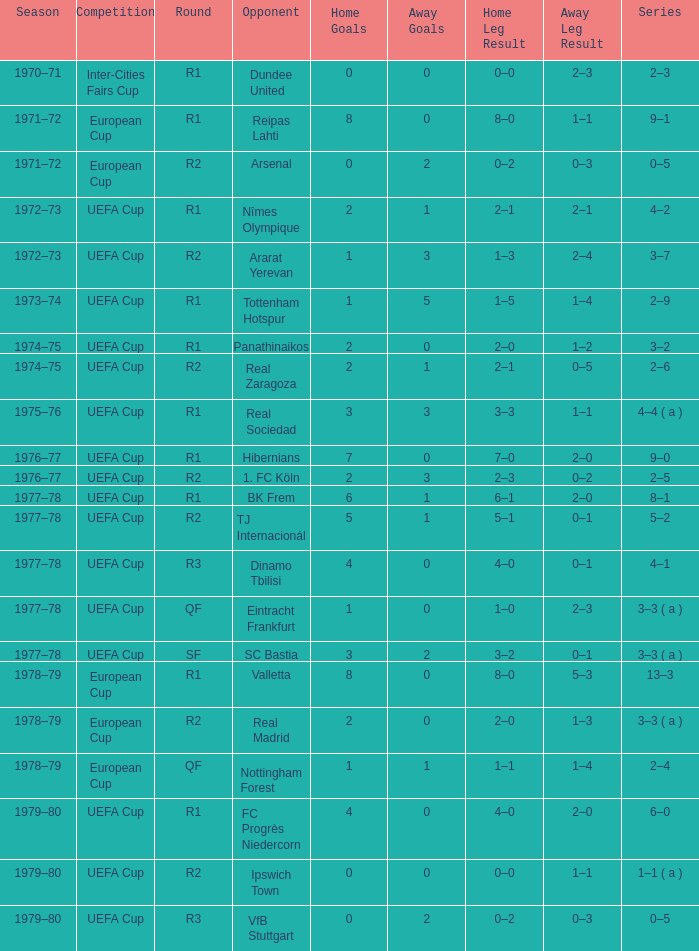Which Opponent has an Away of 1–1, and a Home of 3–3? Real Sociedad. 